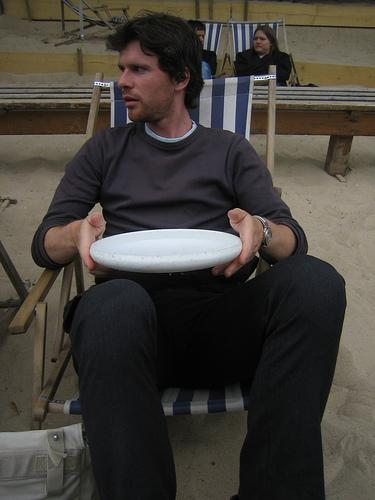What outdoor activity has the man taken a break from?

Choices:
A) baseball
B) basketball
C) frisbee
D) racing frisbee 